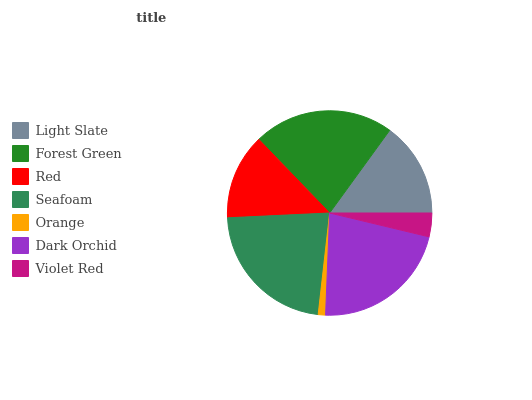Is Orange the minimum?
Answer yes or no. Yes. Is Seafoam the maximum?
Answer yes or no. Yes. Is Forest Green the minimum?
Answer yes or no. No. Is Forest Green the maximum?
Answer yes or no. No. Is Forest Green greater than Light Slate?
Answer yes or no. Yes. Is Light Slate less than Forest Green?
Answer yes or no. Yes. Is Light Slate greater than Forest Green?
Answer yes or no. No. Is Forest Green less than Light Slate?
Answer yes or no. No. Is Light Slate the high median?
Answer yes or no. Yes. Is Light Slate the low median?
Answer yes or no. Yes. Is Forest Green the high median?
Answer yes or no. No. Is Orange the low median?
Answer yes or no. No. 